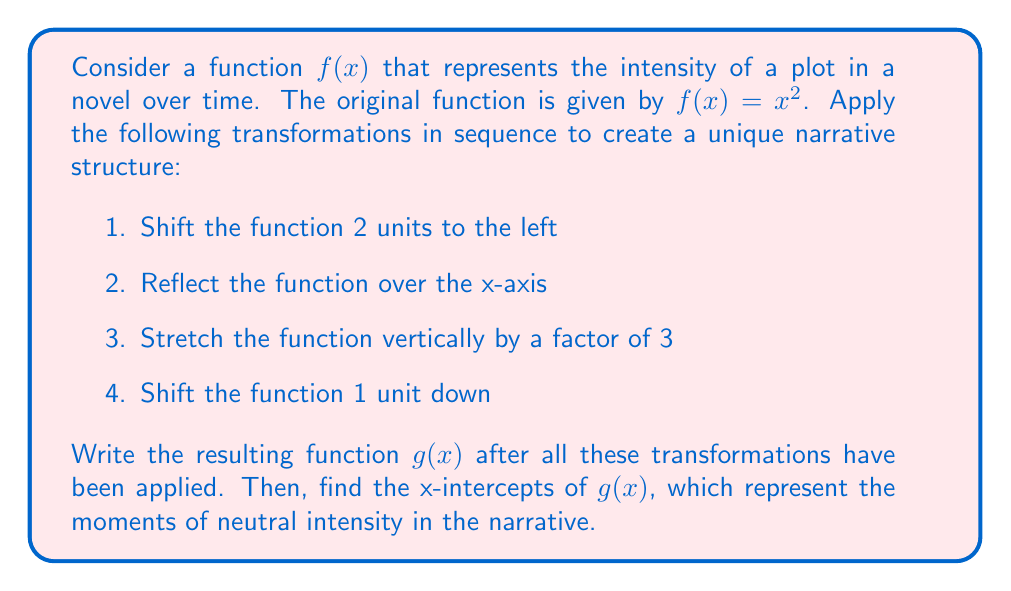What is the answer to this math problem? Let's apply the transformations step by step:

1. Shift 2 units to the left: $f_1(x) = (x+2)^2$

2. Reflect over the x-axis: $f_2(x) = -(x+2)^2$

3. Stretch vertically by a factor of 3: $f_3(x) = -3(x+2)^2$

4. Shift 1 unit down: $g(x) = -3(x+2)^2 - 1$

Now we have our final function $g(x) = -3(x+2)^2 - 1$

To find the x-intercepts, we set $g(x) = 0$:

$$-3(x+2)^2 - 1 = 0$$
$$-3(x+2)^2 = 1$$
$$(x+2)^2 = -\frac{1}{3}$$

Since the square of a real number cannot be negative, there are no real solutions to this equation. This means the function $g(x)$ never crosses the x-axis, and there are no x-intercepts.

Interpreting this in the context of our narrative structure, it suggests that the plot intensity never reaches a neutral point (y = 0) after these transformations. The story always maintains some level of intensity, either positive or negative.
Answer: The resulting function is $g(x) = -3(x+2)^2 - 1$. There are no x-intercepts for this function. 